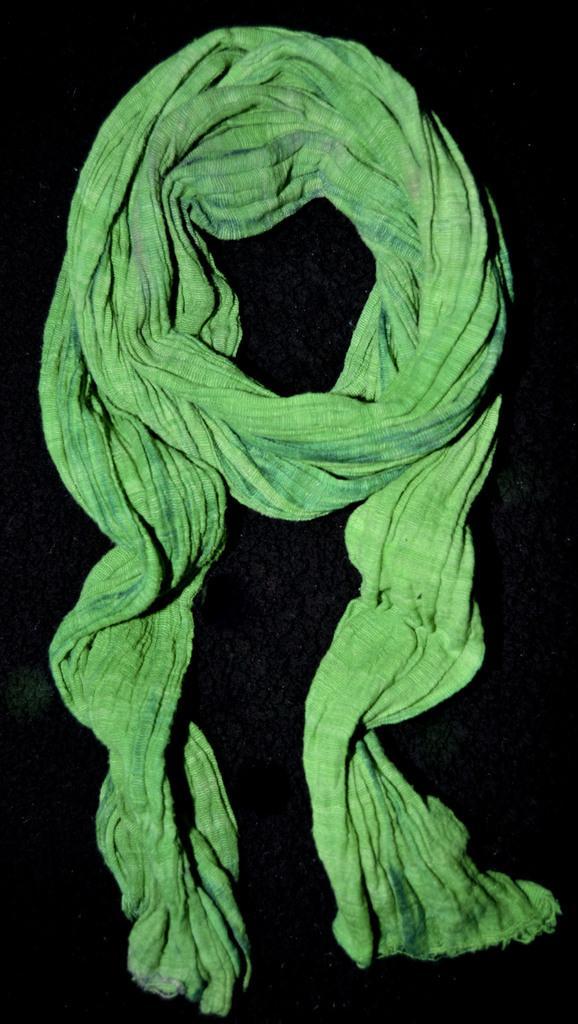Describe this image in one or two sentences. In this picture there is a green color cloth placed on a black surface. 